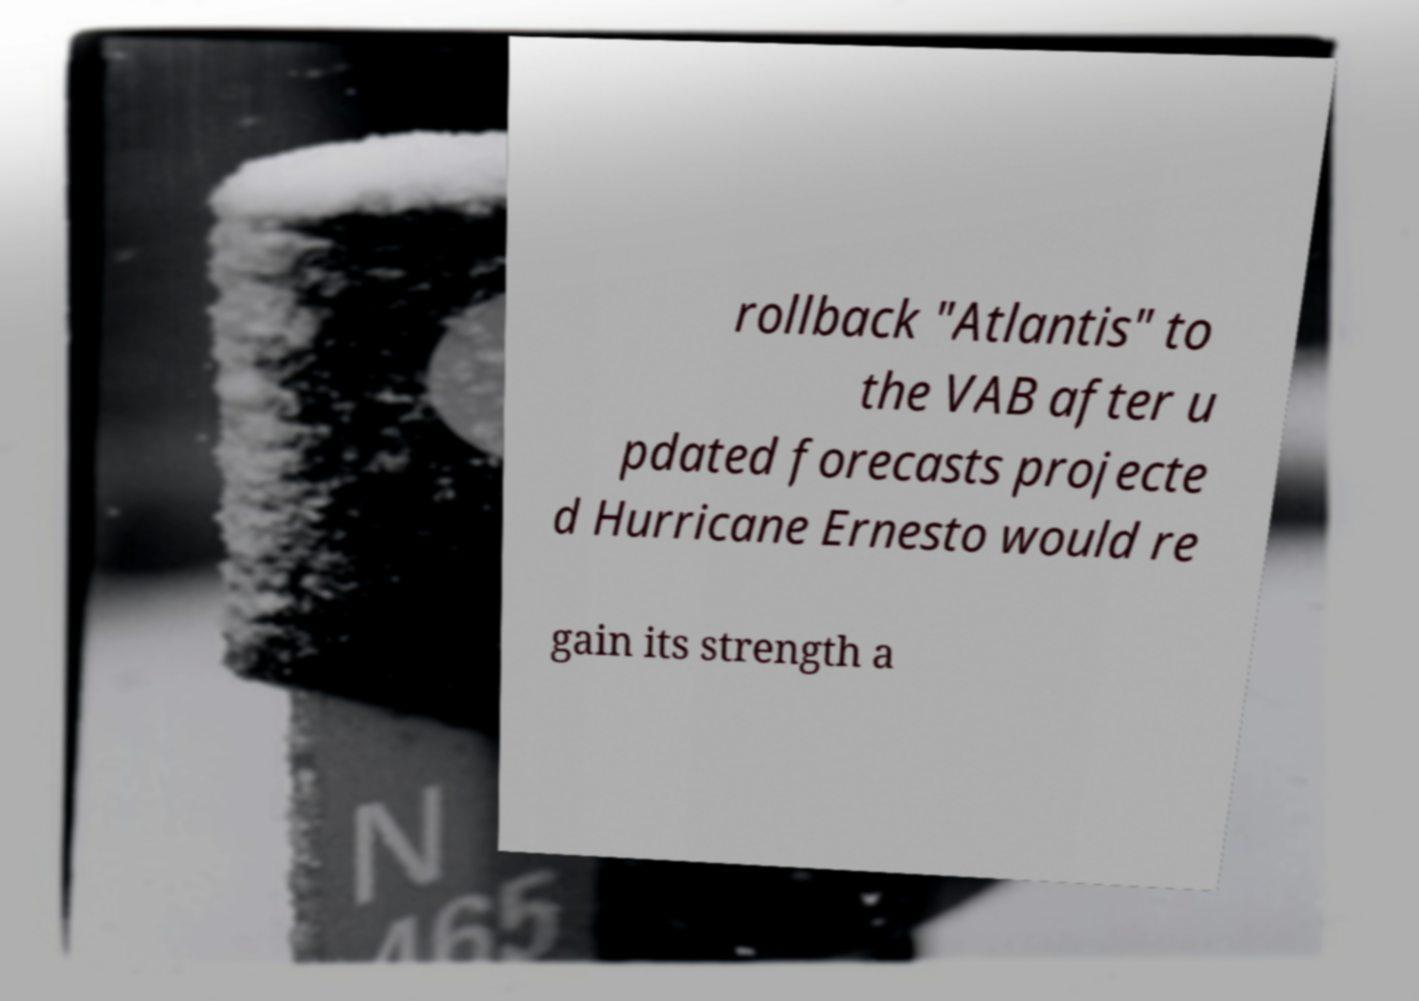Could you assist in decoding the text presented in this image and type it out clearly? rollback "Atlantis" to the VAB after u pdated forecasts projecte d Hurricane Ernesto would re gain its strength a 